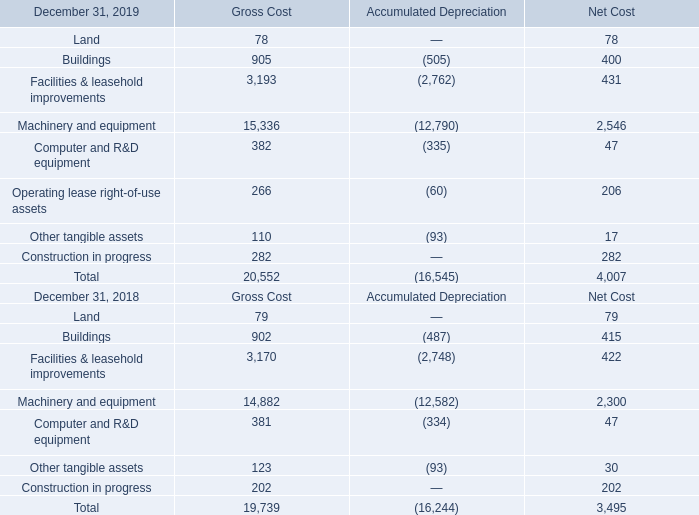The line “Construction in progress” in the table above includes property, plant and equipment under construction and equipment under qualification before operating.
On January 1, 2019, the Company adopted the new guidance on lease accounting and lease right-of-use assets are included in plant, property and equipment. The impact of the adoption of this new guidance is further described in Note 11.
The depreciation charge was $785 million, $727 million and $592 million in 2019, 2018 and 2017, respectively.
As described in Note 7, the acquisition of Norstel resulted in the recognition of property, plant and equipment of $11 million.
What were the new guidelines adopted by the company on January 1, 2019? On january 1, 2019, the company adopted the new guidance on lease accounting and lease right-of-use assets are included in plant, property and equipment. How much recognition of property, plant and equipment led to the acquisition of Norstel? $11 million. What were the depreciation charge for 2019, 2018 and 2017? The depreciation charge was $785 million, $727 million and $592 million in 2019, 2018 and 2017, respectively. What is the average Gross Cost?
Answer scale should be: million. (20,552+19,739) / 2
Answer: 20145.5. What is the average Accumulated Depreciation?
Answer scale should be: million. (16,545+16,244) / 2
Answer: 16394.5. What is the average Net Cost?
Answer scale should be: million. (4,007+3,495) / 2
Answer: 3751. 